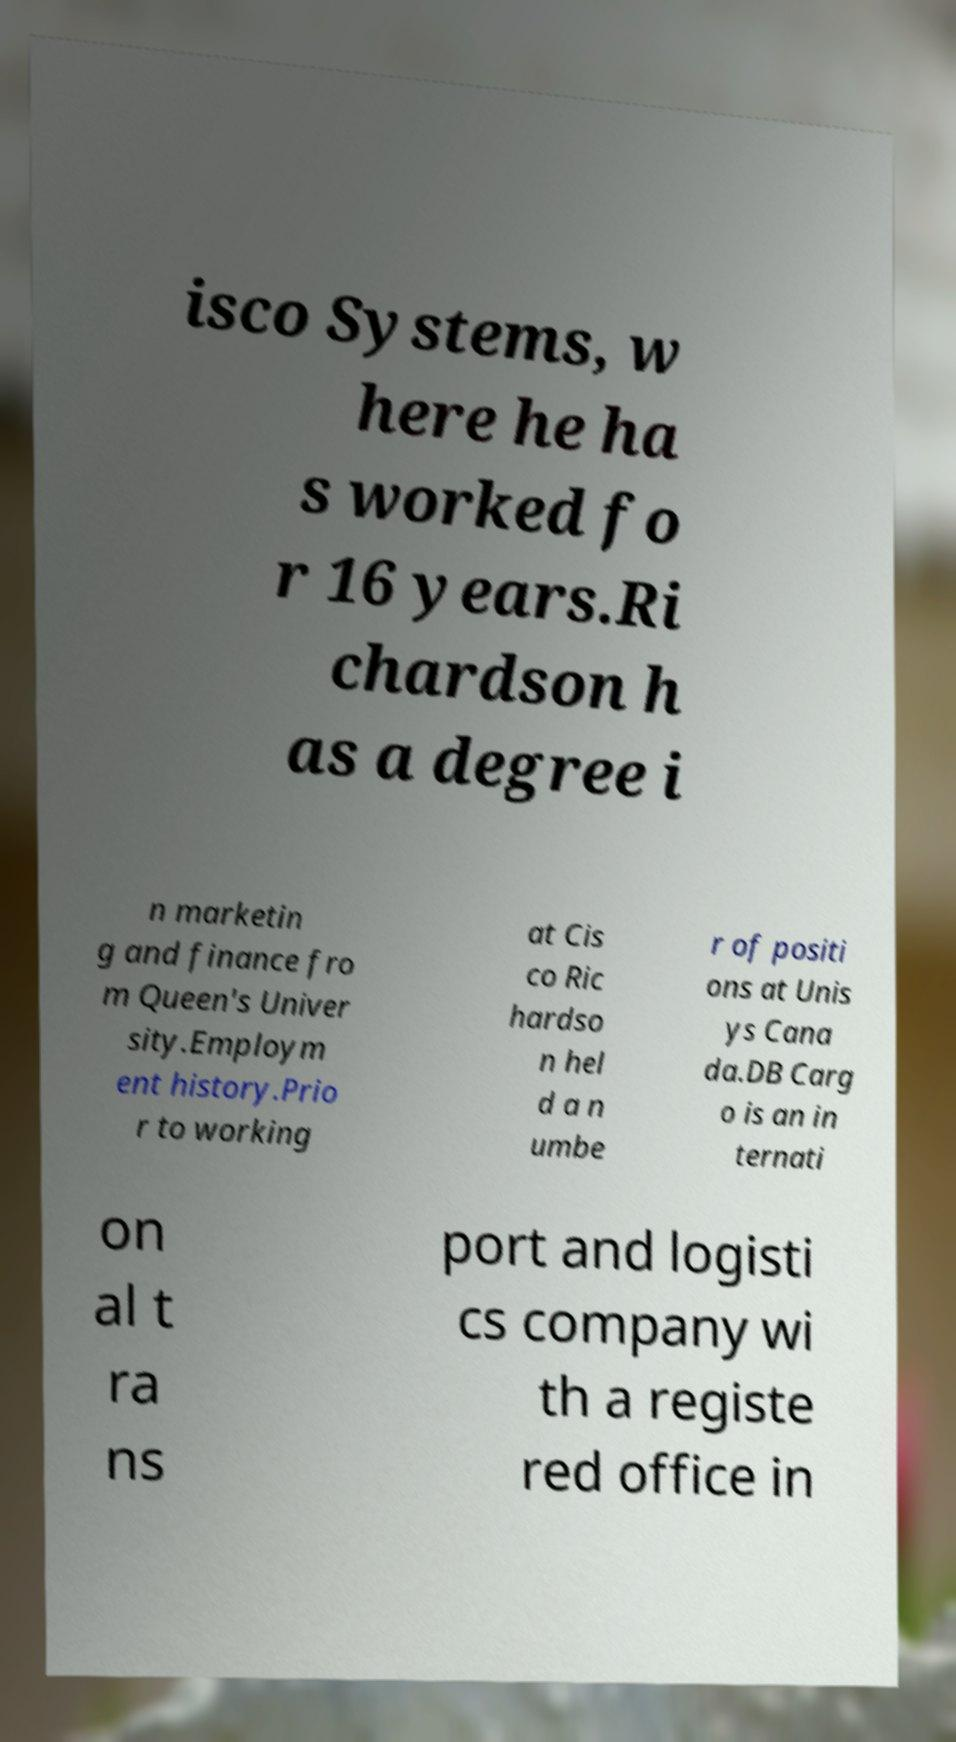Could you extract and type out the text from this image? isco Systems, w here he ha s worked fo r 16 years.Ri chardson h as a degree i n marketin g and finance fro m Queen's Univer sity.Employm ent history.Prio r to working at Cis co Ric hardso n hel d a n umbe r of positi ons at Unis ys Cana da.DB Carg o is an in ternati on al t ra ns port and logisti cs company wi th a registe red office in 